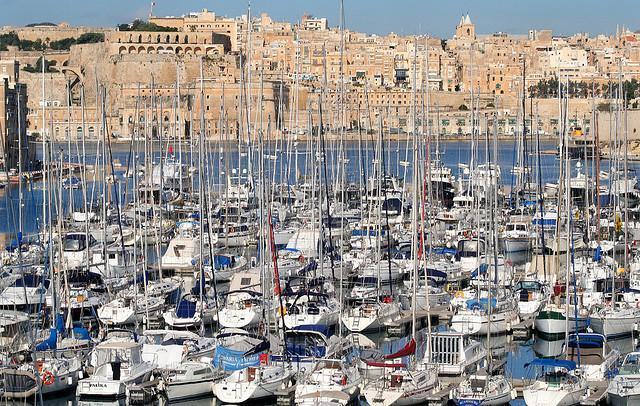How many boats are there?
Give a very brief answer. 10. 